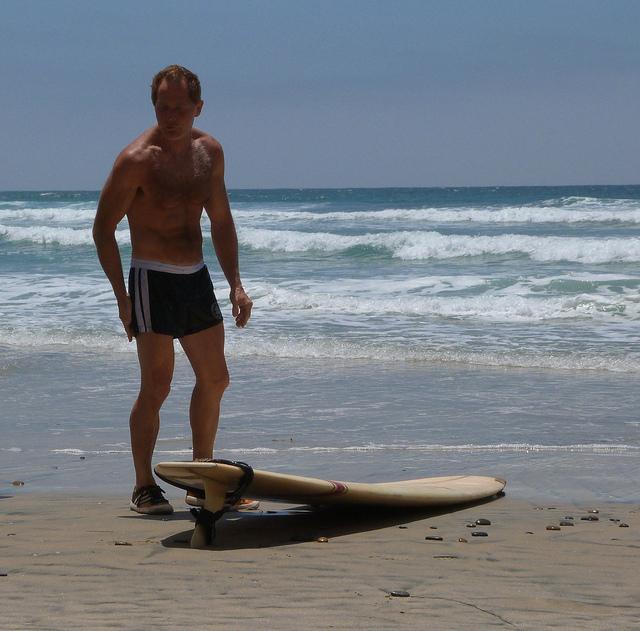What is the color of the surfboard?
Answer briefly. White. Is the guy standing or sitting on the beach?
Give a very brief answer. Standing. Does the guy look disappointed?
Quick response, please. No. Is the surfboard attached to the person?
Short answer required. No. Is the man swimming?
Keep it brief. No. What is the guy on the beach wearing?
Short answer required. Shorts. What is this man on the beach doing with his hands?
Answer briefly. Nothing. What is at the man's feet?
Short answer required. Surfboard. Is the person wet?
Quick response, please. No. How many fins does the board have?
Write a very short answer. 1. How many fins are on the board?
Answer briefly. 1. Is the tide coming in?
Concise answer only. Yes. Does the man have any type of body modification?
Short answer required. No. Is this man holding a drink?
Write a very short answer. No. Is the man wearing glasses?
Short answer required. No. 